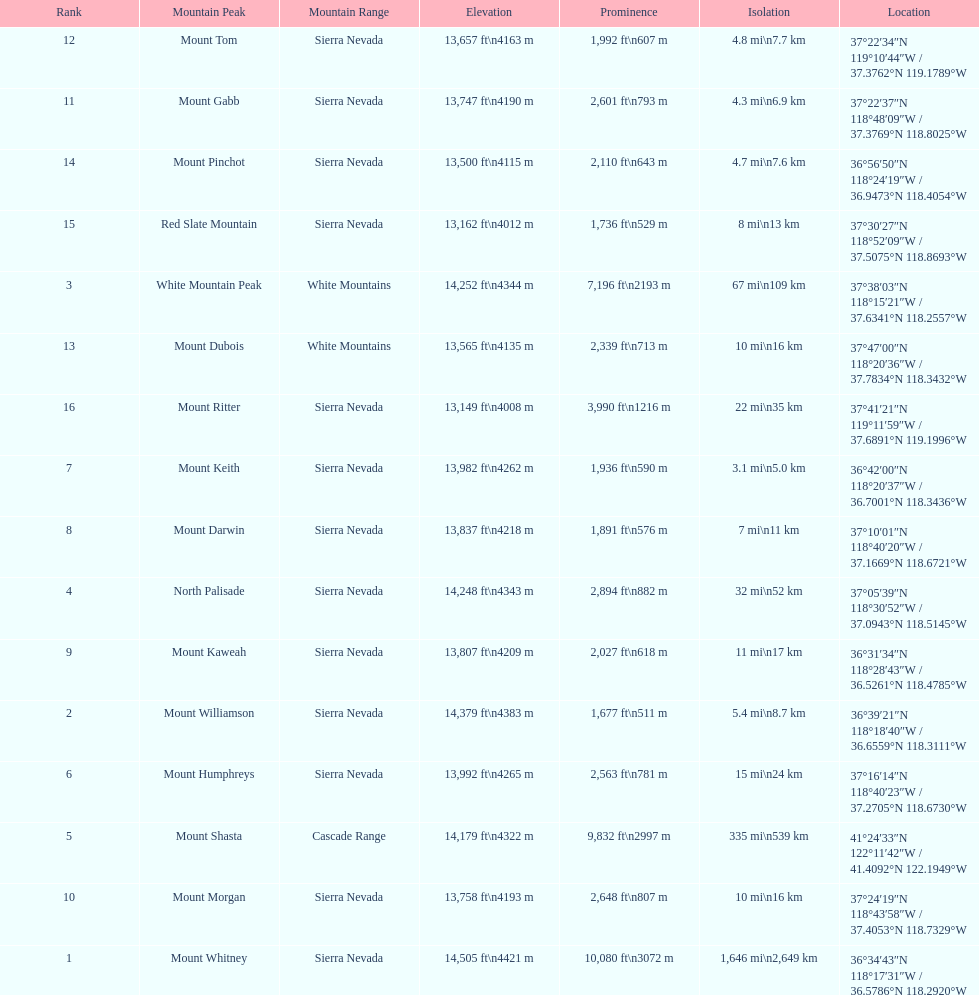Which mountain peak is no higher than 13,149 ft? Mount Ritter. 